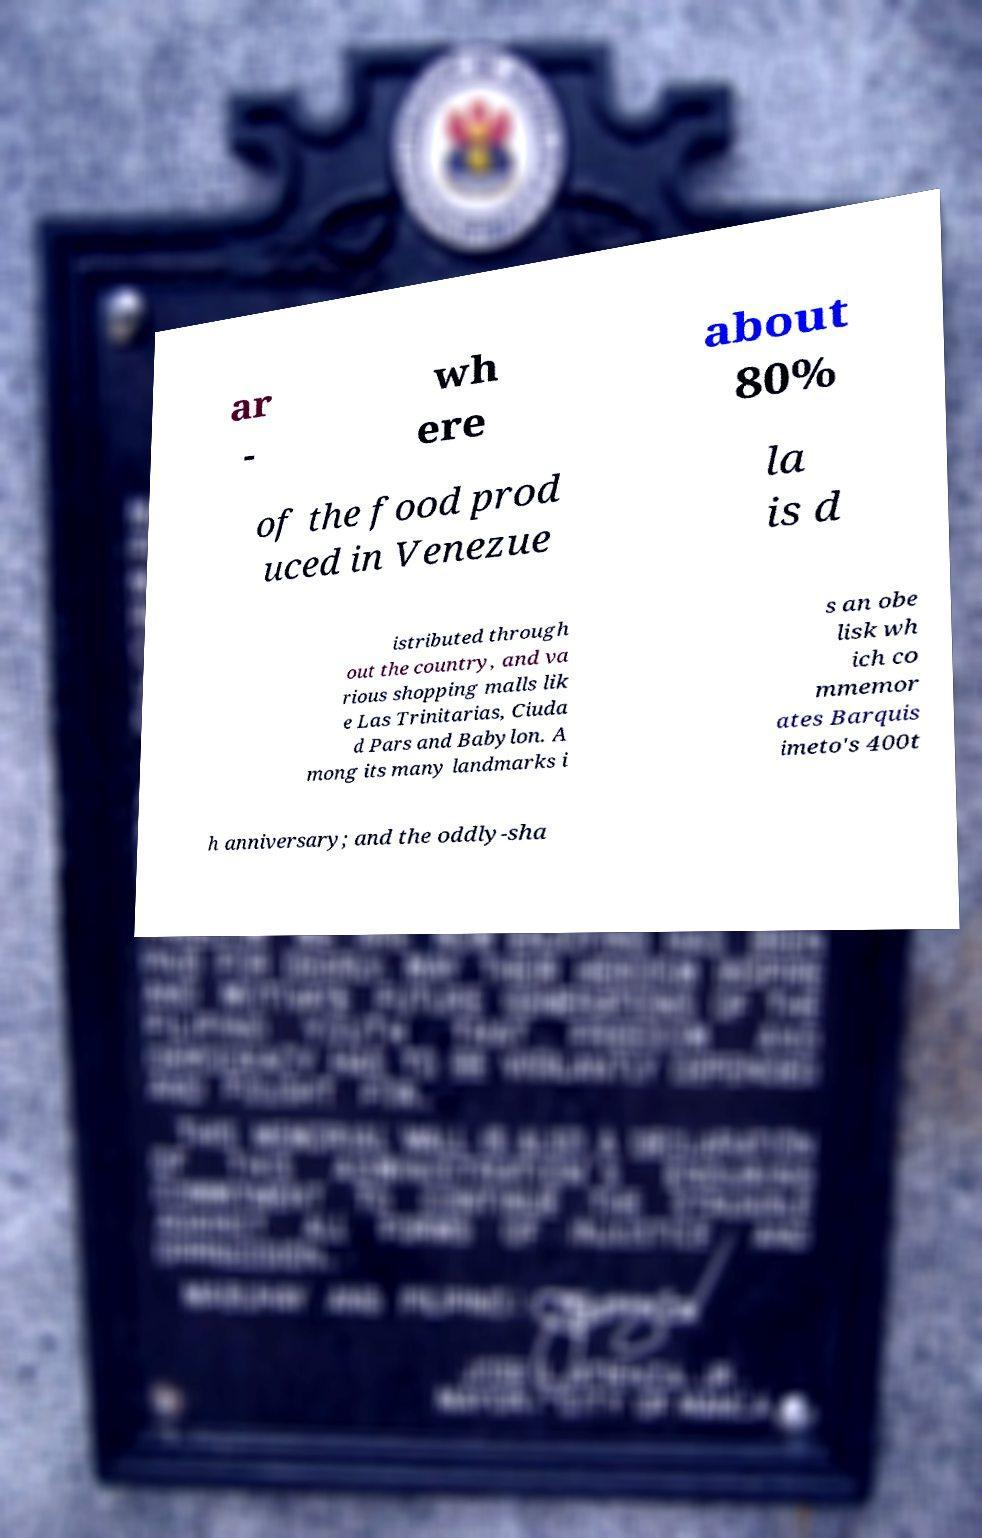What messages or text are displayed in this image? I need them in a readable, typed format. ar - wh ere about 80% of the food prod uced in Venezue la is d istributed through out the country, and va rious shopping malls lik e Las Trinitarias, Ciuda d Pars and Babylon. A mong its many landmarks i s an obe lisk wh ich co mmemor ates Barquis imeto's 400t h anniversary; and the oddly-sha 